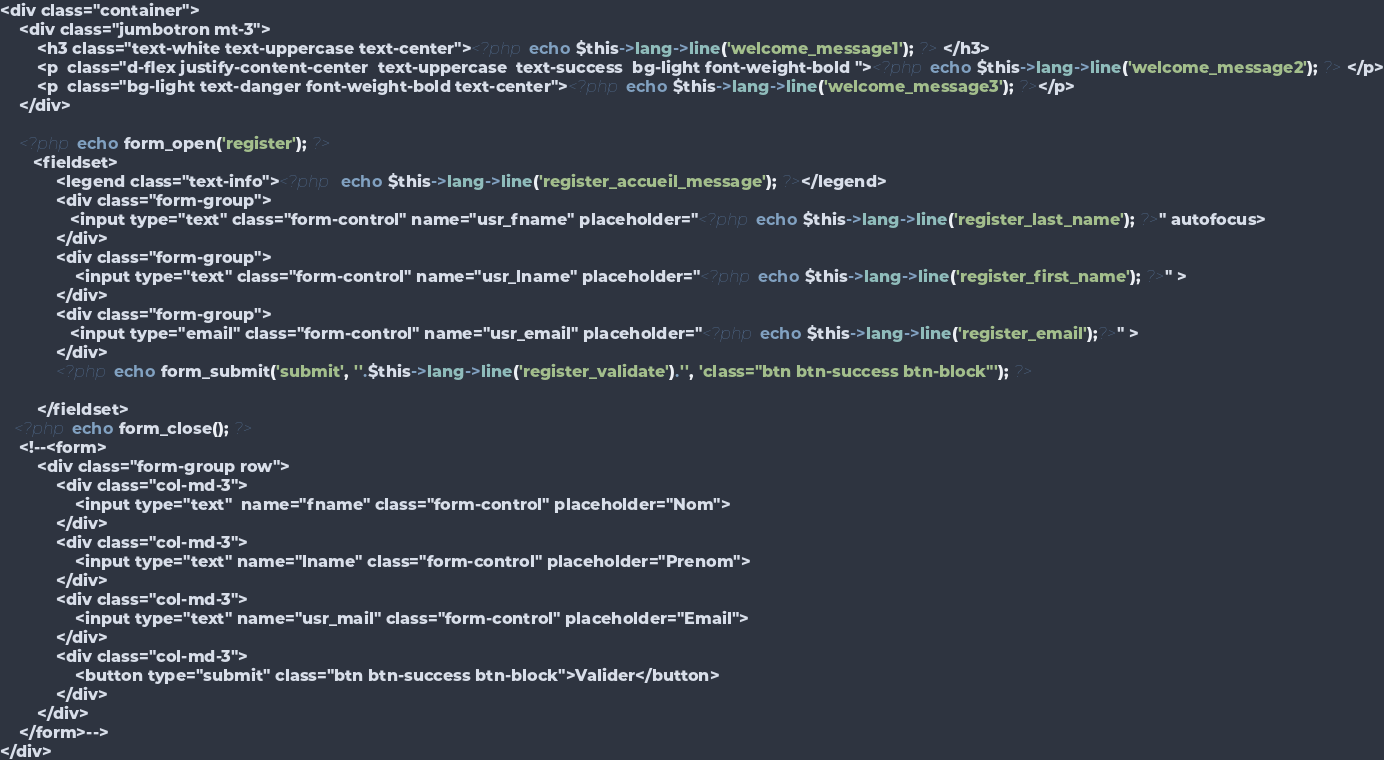Convert code to text. <code><loc_0><loc_0><loc_500><loc_500><_PHP_><div class="container">
    <div class="jumbotron mt-3">
        <h3 class="text-white text-uppercase text-center"><?php echo $this->lang->line('welcome_message1'); ?> </h3>
        <p  class="d-flex justify-content-center  text-uppercase  text-success  bg-light font-weight-bold "><?php echo $this->lang->line('welcome_message2'); ?> </p>
        <p  class="bg-light text-danger font-weight-bold text-center"><?php echo $this->lang->line('welcome_message3'); ?></p>
    </div>

    <?php echo form_open('register'); ?> 
       <fieldset>   
            <legend class="text-info"><?php  echo $this->lang->line('register_accueil_message'); ?></legend>
            <div class="form-group">
               <input type="text" class="form-control" name="usr_fname" placeholder="<?php echo $this->lang->line('register_last_name'); ?>" autofocus>
            </div>
            <div class="form-group">
                <input type="text" class="form-control" name="usr_lname" placeholder="<?php echo $this->lang->line('register_first_name'); ?>" >
            </div>
            <div class="form-group">
               <input type="email" class="form-control" name="usr_email" placeholder="<?php echo $this->lang->line('register_email');?>" >
            </div>
            <?php echo form_submit('submit', ''.$this->lang->line('register_validate').'', 'class="btn btn-success btn-block"'); ?>

        </fieldset>
   <?php echo form_close(); ?>
    <!--<form>
        <div class="form-group row">
            <div class="col-md-3">
                <input type="text"  name="fname" class="form-control" placeholder="Nom">
            </div>
            <div class="col-md-3">
                <input type="text" name="lname" class="form-control" placeholder="Prenom">
            </div>
            <div class="col-md-3">
                <input type="text" name="usr_mail" class="form-control" placeholder="Email">
            </div>
            <div class="col-md-3">
                <button type="submit" class="btn btn-success btn-block">Valider</button>
            </div>
        </div>
    </form>-->
</div></code> 